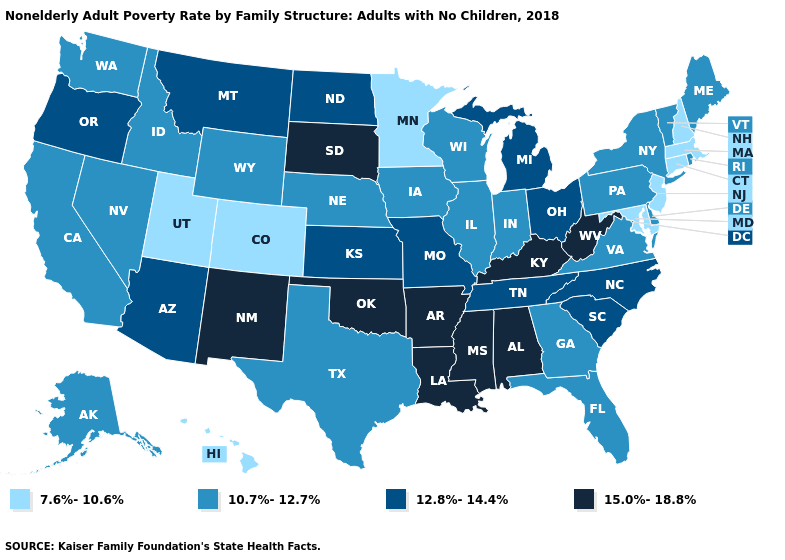Among the states that border Wisconsin , does Illinois have the lowest value?
Quick response, please. No. What is the value of Arizona?
Keep it brief. 12.8%-14.4%. What is the value of Alabama?
Write a very short answer. 15.0%-18.8%. Name the states that have a value in the range 12.8%-14.4%?
Short answer required. Arizona, Kansas, Michigan, Missouri, Montana, North Carolina, North Dakota, Ohio, Oregon, South Carolina, Tennessee. What is the value of California?
Write a very short answer. 10.7%-12.7%. Name the states that have a value in the range 7.6%-10.6%?
Quick response, please. Colorado, Connecticut, Hawaii, Maryland, Massachusetts, Minnesota, New Hampshire, New Jersey, Utah. Does California have a higher value than Maryland?
Keep it brief. Yes. What is the value of Illinois?
Write a very short answer. 10.7%-12.7%. What is the value of Kentucky?
Keep it brief. 15.0%-18.8%. Does the map have missing data?
Give a very brief answer. No. Which states have the highest value in the USA?
Write a very short answer. Alabama, Arkansas, Kentucky, Louisiana, Mississippi, New Mexico, Oklahoma, South Dakota, West Virginia. Does Wisconsin have the highest value in the USA?
Short answer required. No. What is the highest value in the USA?
Give a very brief answer. 15.0%-18.8%. What is the value of Oklahoma?
Give a very brief answer. 15.0%-18.8%. What is the highest value in the West ?
Concise answer only. 15.0%-18.8%. 